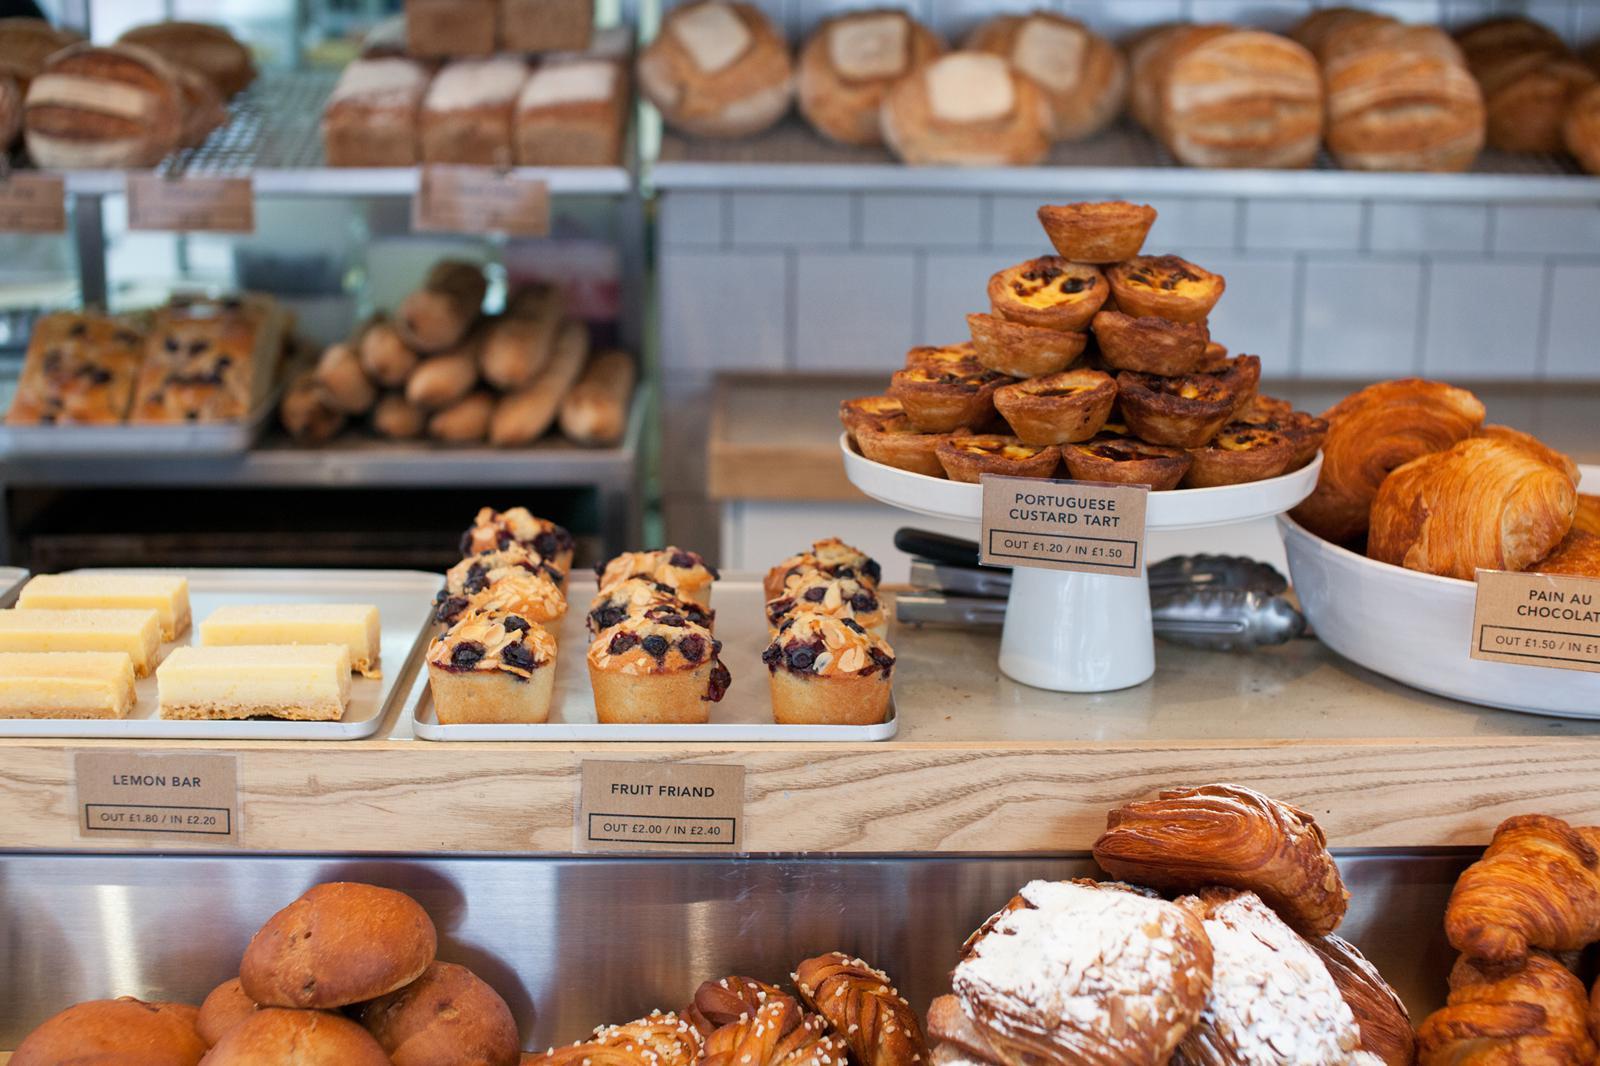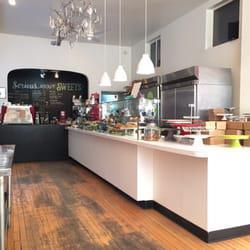The first image is the image on the left, the second image is the image on the right. Considering the images on both sides, is "The left image includes a baked item displayed on a pedestal." valid? Answer yes or no. Yes. The first image is the image on the left, the second image is the image on the right. Given the left and right images, does the statement "There is a chalkboard with writing on it." hold true? Answer yes or no. Yes. 